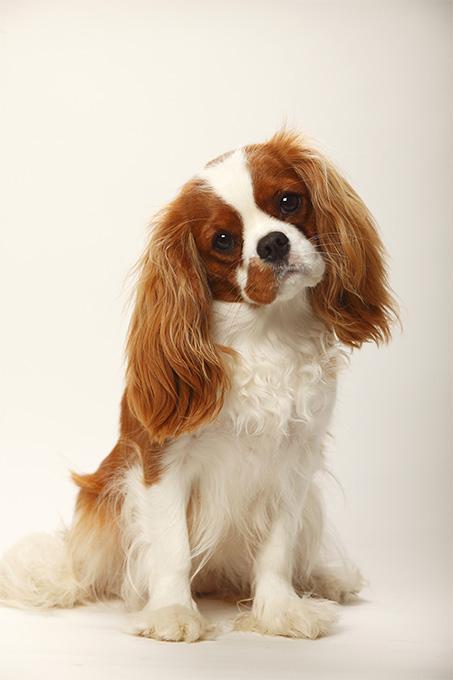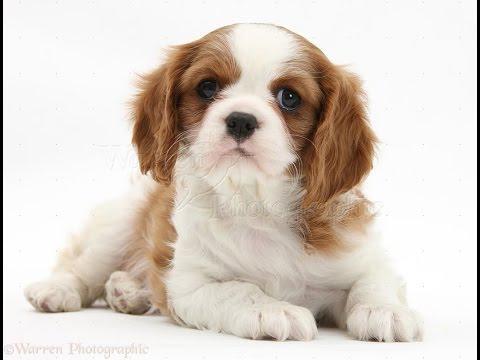The first image is the image on the left, the second image is the image on the right. Given the left and right images, does the statement "There are a total of three cocker spaniels" hold true? Answer yes or no. No. The first image is the image on the left, the second image is the image on the right. Given the left and right images, does the statement "One image includes twice as many dogs as the other image." hold true? Answer yes or no. No. 